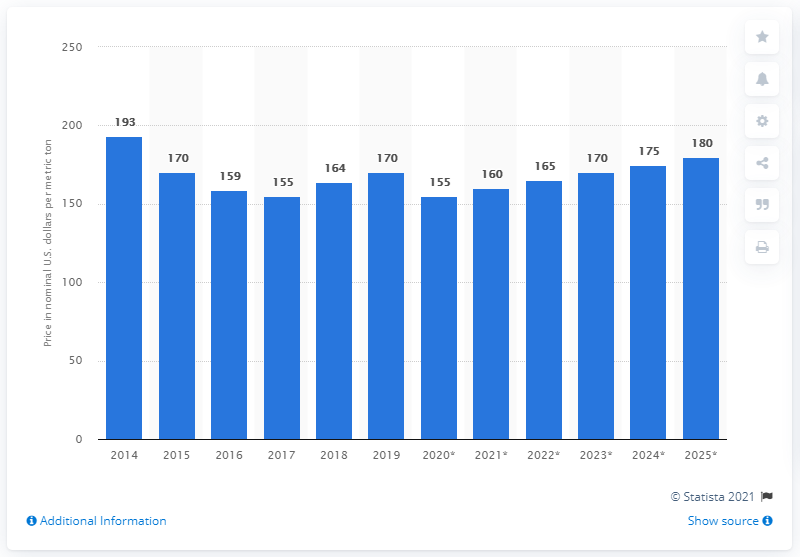Highlight a few significant elements in this photo. In 2019, the average price per metric ton for maize was 170. 